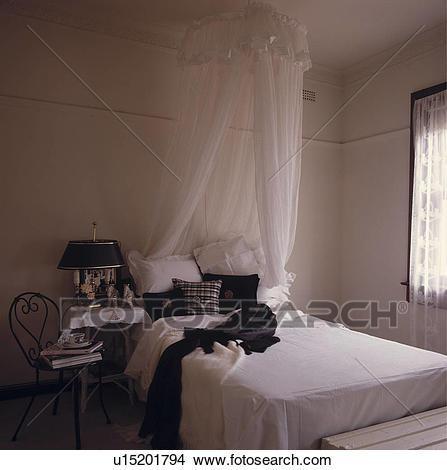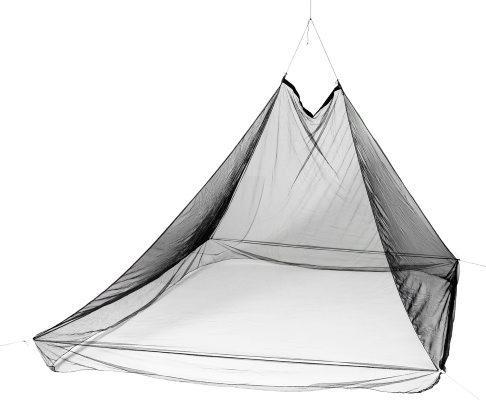The first image is the image on the left, the second image is the image on the right. Assess this claim about the two images: "In the left image, all pillows are white.". Correct or not? Answer yes or no. No. 